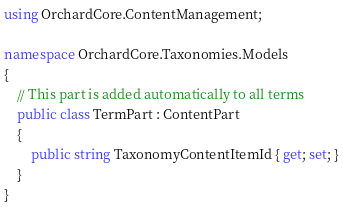Convert code to text. <code><loc_0><loc_0><loc_500><loc_500><_C#_>using OrchardCore.ContentManagement;

namespace OrchardCore.Taxonomies.Models
{
    // This part is added automatically to all terms
    public class TermPart : ContentPart
    {
        public string TaxonomyContentItemId { get; set; }
    }
}
</code> 